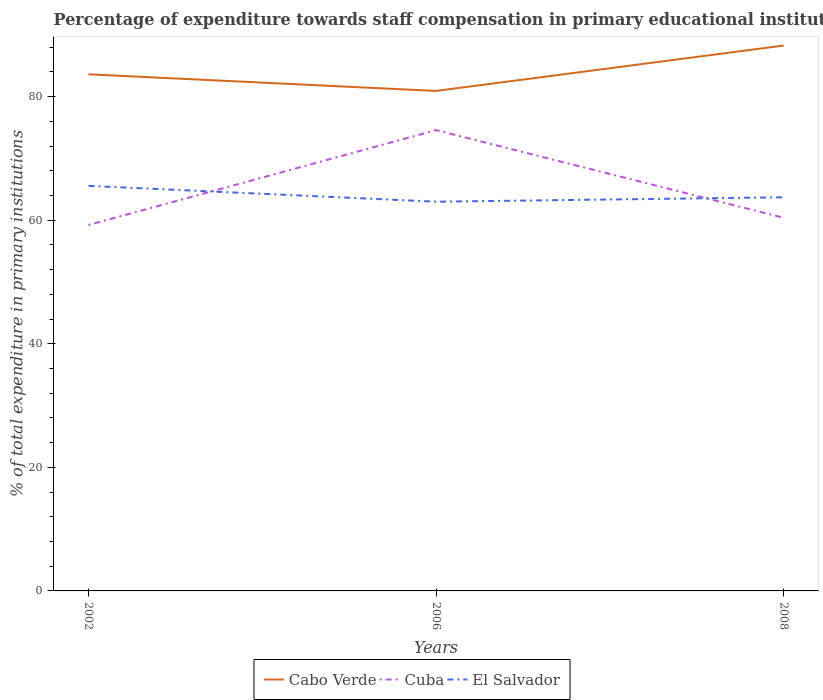How many different coloured lines are there?
Your answer should be compact. 3. Does the line corresponding to Cabo Verde intersect with the line corresponding to Cuba?
Make the answer very short. No. Across all years, what is the maximum percentage of expenditure towards staff compensation in Cuba?
Your response must be concise. 59.22. What is the total percentage of expenditure towards staff compensation in Cabo Verde in the graph?
Give a very brief answer. 2.69. What is the difference between the highest and the second highest percentage of expenditure towards staff compensation in Cuba?
Offer a very short reply. 15.35. Is the percentage of expenditure towards staff compensation in Cabo Verde strictly greater than the percentage of expenditure towards staff compensation in Cuba over the years?
Provide a short and direct response. No. How many lines are there?
Make the answer very short. 3. How many years are there in the graph?
Provide a short and direct response. 3. What is the difference between two consecutive major ticks on the Y-axis?
Provide a succinct answer. 20. Are the values on the major ticks of Y-axis written in scientific E-notation?
Offer a terse response. No. How many legend labels are there?
Make the answer very short. 3. What is the title of the graph?
Your answer should be very brief. Percentage of expenditure towards staff compensation in primary educational institutions. Does "Maldives" appear as one of the legend labels in the graph?
Give a very brief answer. No. What is the label or title of the X-axis?
Keep it short and to the point. Years. What is the label or title of the Y-axis?
Your answer should be compact. % of total expenditure in primary institutions. What is the % of total expenditure in primary institutions of Cabo Verde in 2002?
Give a very brief answer. 83.6. What is the % of total expenditure in primary institutions of Cuba in 2002?
Offer a terse response. 59.22. What is the % of total expenditure in primary institutions in El Salvador in 2002?
Offer a very short reply. 65.55. What is the % of total expenditure in primary institutions in Cabo Verde in 2006?
Your response must be concise. 80.91. What is the % of total expenditure in primary institutions in Cuba in 2006?
Your answer should be compact. 74.57. What is the % of total expenditure in primary institutions in El Salvador in 2006?
Provide a succinct answer. 62.99. What is the % of total expenditure in primary institutions of Cabo Verde in 2008?
Your answer should be very brief. 88.26. What is the % of total expenditure in primary institutions of Cuba in 2008?
Make the answer very short. 60.38. What is the % of total expenditure in primary institutions of El Salvador in 2008?
Offer a terse response. 63.7. Across all years, what is the maximum % of total expenditure in primary institutions in Cabo Verde?
Keep it short and to the point. 88.26. Across all years, what is the maximum % of total expenditure in primary institutions of Cuba?
Your answer should be compact. 74.57. Across all years, what is the maximum % of total expenditure in primary institutions in El Salvador?
Make the answer very short. 65.55. Across all years, what is the minimum % of total expenditure in primary institutions of Cabo Verde?
Your response must be concise. 80.91. Across all years, what is the minimum % of total expenditure in primary institutions of Cuba?
Keep it short and to the point. 59.22. Across all years, what is the minimum % of total expenditure in primary institutions in El Salvador?
Your answer should be very brief. 62.99. What is the total % of total expenditure in primary institutions of Cabo Verde in the graph?
Keep it short and to the point. 252.77. What is the total % of total expenditure in primary institutions in Cuba in the graph?
Your answer should be very brief. 194.17. What is the total % of total expenditure in primary institutions in El Salvador in the graph?
Make the answer very short. 192.24. What is the difference between the % of total expenditure in primary institutions of Cabo Verde in 2002 and that in 2006?
Your answer should be very brief. 2.69. What is the difference between the % of total expenditure in primary institutions of Cuba in 2002 and that in 2006?
Your response must be concise. -15.35. What is the difference between the % of total expenditure in primary institutions in El Salvador in 2002 and that in 2006?
Give a very brief answer. 2.56. What is the difference between the % of total expenditure in primary institutions in Cabo Verde in 2002 and that in 2008?
Make the answer very short. -4.65. What is the difference between the % of total expenditure in primary institutions in Cuba in 2002 and that in 2008?
Your answer should be very brief. -1.16. What is the difference between the % of total expenditure in primary institutions of El Salvador in 2002 and that in 2008?
Your answer should be very brief. 1.84. What is the difference between the % of total expenditure in primary institutions of Cabo Verde in 2006 and that in 2008?
Keep it short and to the point. -7.34. What is the difference between the % of total expenditure in primary institutions of Cuba in 2006 and that in 2008?
Your answer should be compact. 14.19. What is the difference between the % of total expenditure in primary institutions in El Salvador in 2006 and that in 2008?
Provide a succinct answer. -0.71. What is the difference between the % of total expenditure in primary institutions of Cabo Verde in 2002 and the % of total expenditure in primary institutions of Cuba in 2006?
Offer a terse response. 9.03. What is the difference between the % of total expenditure in primary institutions of Cabo Verde in 2002 and the % of total expenditure in primary institutions of El Salvador in 2006?
Offer a terse response. 20.62. What is the difference between the % of total expenditure in primary institutions in Cuba in 2002 and the % of total expenditure in primary institutions in El Salvador in 2006?
Ensure brevity in your answer.  -3.77. What is the difference between the % of total expenditure in primary institutions in Cabo Verde in 2002 and the % of total expenditure in primary institutions in Cuba in 2008?
Your answer should be compact. 23.22. What is the difference between the % of total expenditure in primary institutions of Cabo Verde in 2002 and the % of total expenditure in primary institutions of El Salvador in 2008?
Ensure brevity in your answer.  19.9. What is the difference between the % of total expenditure in primary institutions in Cuba in 2002 and the % of total expenditure in primary institutions in El Salvador in 2008?
Provide a short and direct response. -4.49. What is the difference between the % of total expenditure in primary institutions in Cabo Verde in 2006 and the % of total expenditure in primary institutions in Cuba in 2008?
Your response must be concise. 20.53. What is the difference between the % of total expenditure in primary institutions of Cabo Verde in 2006 and the % of total expenditure in primary institutions of El Salvador in 2008?
Offer a terse response. 17.21. What is the difference between the % of total expenditure in primary institutions of Cuba in 2006 and the % of total expenditure in primary institutions of El Salvador in 2008?
Your answer should be very brief. 10.87. What is the average % of total expenditure in primary institutions of Cabo Verde per year?
Keep it short and to the point. 84.26. What is the average % of total expenditure in primary institutions of Cuba per year?
Your answer should be very brief. 64.72. What is the average % of total expenditure in primary institutions in El Salvador per year?
Ensure brevity in your answer.  64.08. In the year 2002, what is the difference between the % of total expenditure in primary institutions in Cabo Verde and % of total expenditure in primary institutions in Cuba?
Provide a short and direct response. 24.39. In the year 2002, what is the difference between the % of total expenditure in primary institutions in Cabo Verde and % of total expenditure in primary institutions in El Salvador?
Make the answer very short. 18.06. In the year 2002, what is the difference between the % of total expenditure in primary institutions of Cuba and % of total expenditure in primary institutions of El Salvador?
Provide a short and direct response. -6.33. In the year 2006, what is the difference between the % of total expenditure in primary institutions of Cabo Verde and % of total expenditure in primary institutions of Cuba?
Keep it short and to the point. 6.34. In the year 2006, what is the difference between the % of total expenditure in primary institutions in Cabo Verde and % of total expenditure in primary institutions in El Salvador?
Give a very brief answer. 17.92. In the year 2006, what is the difference between the % of total expenditure in primary institutions in Cuba and % of total expenditure in primary institutions in El Salvador?
Your answer should be very brief. 11.58. In the year 2008, what is the difference between the % of total expenditure in primary institutions of Cabo Verde and % of total expenditure in primary institutions of Cuba?
Provide a short and direct response. 27.88. In the year 2008, what is the difference between the % of total expenditure in primary institutions of Cabo Verde and % of total expenditure in primary institutions of El Salvador?
Keep it short and to the point. 24.55. In the year 2008, what is the difference between the % of total expenditure in primary institutions of Cuba and % of total expenditure in primary institutions of El Salvador?
Provide a succinct answer. -3.32. What is the ratio of the % of total expenditure in primary institutions in Cuba in 2002 to that in 2006?
Give a very brief answer. 0.79. What is the ratio of the % of total expenditure in primary institutions in El Salvador in 2002 to that in 2006?
Keep it short and to the point. 1.04. What is the ratio of the % of total expenditure in primary institutions in Cabo Verde in 2002 to that in 2008?
Provide a short and direct response. 0.95. What is the ratio of the % of total expenditure in primary institutions of Cuba in 2002 to that in 2008?
Your answer should be compact. 0.98. What is the ratio of the % of total expenditure in primary institutions in El Salvador in 2002 to that in 2008?
Your response must be concise. 1.03. What is the ratio of the % of total expenditure in primary institutions of Cabo Verde in 2006 to that in 2008?
Offer a terse response. 0.92. What is the ratio of the % of total expenditure in primary institutions of Cuba in 2006 to that in 2008?
Your answer should be compact. 1.24. What is the difference between the highest and the second highest % of total expenditure in primary institutions in Cabo Verde?
Your answer should be very brief. 4.65. What is the difference between the highest and the second highest % of total expenditure in primary institutions in Cuba?
Offer a terse response. 14.19. What is the difference between the highest and the second highest % of total expenditure in primary institutions in El Salvador?
Give a very brief answer. 1.84. What is the difference between the highest and the lowest % of total expenditure in primary institutions of Cabo Verde?
Your answer should be very brief. 7.34. What is the difference between the highest and the lowest % of total expenditure in primary institutions of Cuba?
Keep it short and to the point. 15.35. What is the difference between the highest and the lowest % of total expenditure in primary institutions of El Salvador?
Make the answer very short. 2.56. 